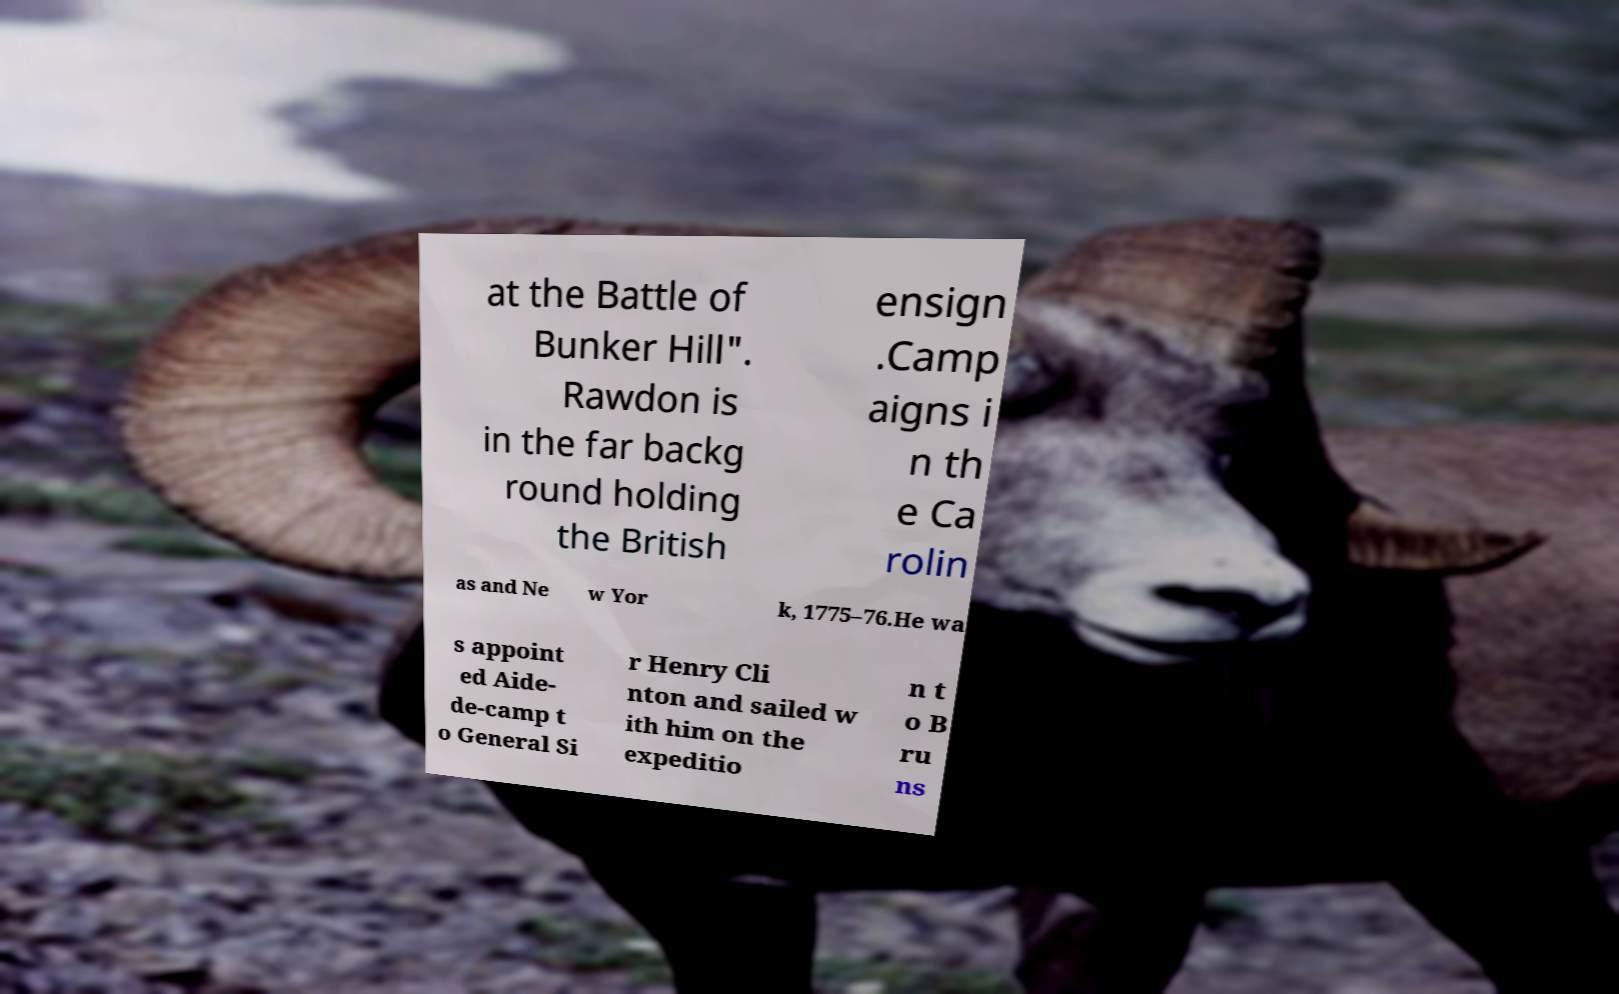For documentation purposes, I need the text within this image transcribed. Could you provide that? at the Battle of Bunker Hill". Rawdon is in the far backg round holding the British ensign .Camp aigns i n th e Ca rolin as and Ne w Yor k, 1775–76.He wa s appoint ed Aide- de-camp t o General Si r Henry Cli nton and sailed w ith him on the expeditio n t o B ru ns 